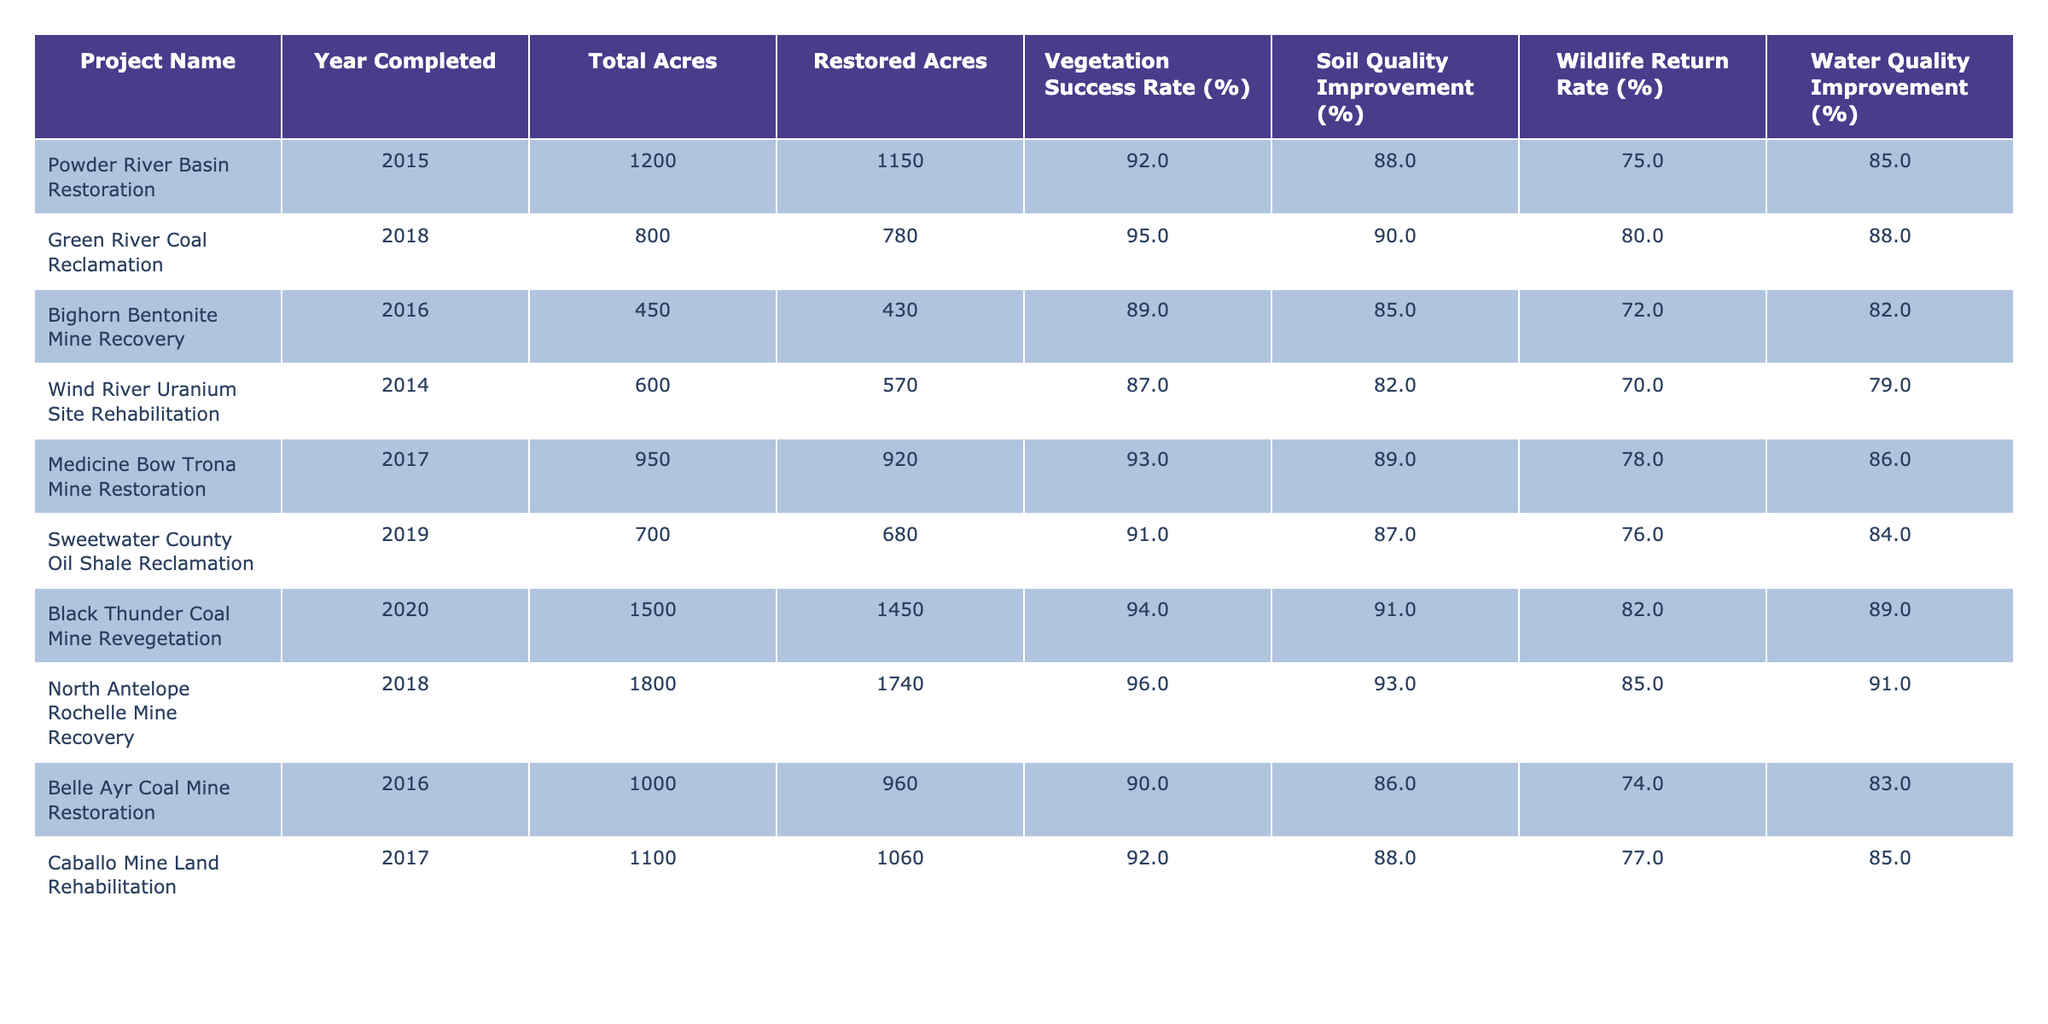What is the vegetation success rate for the North Antelope Rochelle Mine Recovery project? The table shows the vegetation success rate listed under the North Antelope Rochelle Mine Recovery, which is 96%.
Answer: 96% Which project had the highest wildlife return rate? By comparing the wildlife return rates across all projects in the table, the North Antelope Rochelle Mine Recovery has the highest rate at 85%.
Answer: 85% What is the total acres restored for the Belle Ayr Coal Mine Restoration? The total acres restored for the Belle Ayr Coal Mine Restoration is 960 acres as noted in the corresponding row in the table.
Answer: 960 Calculate the average water quality improvement percentage across all projects. First, sum all the water quality improvement percentages: (85 + 88 + 82 + 79 + 86 + 84 + 89 + 91 + 83 + 85) = 839. Then divide by the number of projects, which is 10: 839 / 10 = 83.9%.
Answer: 83.9% Did the Sweetwater County Oil Shale Reclamation project achieve a vegetation success rate above 90%? The table indicates that the vegetation success rate for this project is 91%, which is above 90%.
Answer: Yes What is the difference in total acres between the Black Thunder Coal Mine Revegetation project and the Wind River Uranium Site Rehabilitation project? The total acres of Black Thunder Coal Mine Revegetation is 1500 and for Wind River Uranium Site Rehabilitation is 600. The difference is 1500 - 600 = 900 acres.
Answer: 900 List the projects completed in 2016 and their restoration success rates. The projects completed in 2016 are the Bighorn Bentonite Mine Recovery (89%), and Belle Ayr Coal Mine Restoration (90%).
Answer: Bighorn Bentonite Mine Recovery: 89%, Belle Ayr Coal Mine Restoration: 90% Which project had a soil quality improvement below 85%? From the table, the Bighorn Bentonite Mine Recovery has a soil quality improvement of 85%, and Wind River Uranium Site Rehabilitation has 82%, making Wind River the only one below 85%.
Answer: Wind River Uranium Site Rehabilitation What is the total acres restored across all projects listed? Sum the restored acres from each project: 1150 + 780 + 430 + 570 + 920 + 680 + 1450 + 1740 + 960 + 1060 = 10,740 acres restored in total.
Answer: 10,740 Is there any project that has achieved a soil quality improvement rate of over 90%? The table indicates that both the North Antelope Rochelle Mine Recovery (93%) and Black Thunder Coal Mine Revegetation (91%) have achieved soil quality improvement rates over 90%.
Answer: Yes 